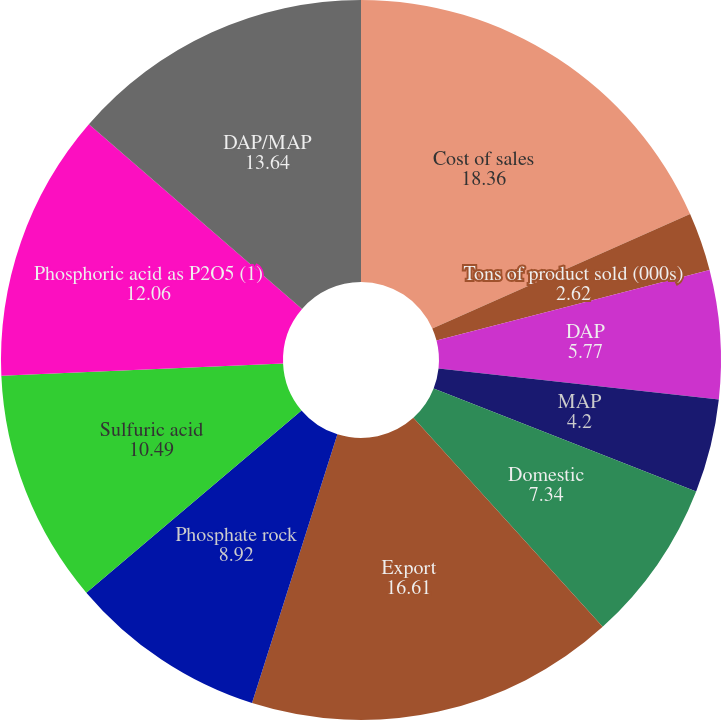<chart> <loc_0><loc_0><loc_500><loc_500><pie_chart><fcel>Cost of sales<fcel>Tons of product sold (000s)<fcel>DAP<fcel>MAP<fcel>Domestic<fcel>Export<fcel>Phosphate rock<fcel>Sulfuric acid<fcel>Phosphoric acid as P2O5 (1)<fcel>DAP/MAP<nl><fcel>18.36%<fcel>2.62%<fcel>5.77%<fcel>4.2%<fcel>7.34%<fcel>16.61%<fcel>8.92%<fcel>10.49%<fcel>12.06%<fcel>13.64%<nl></chart> 